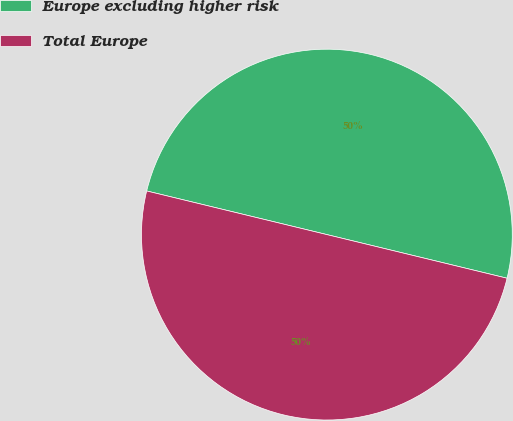Convert chart to OTSL. <chart><loc_0><loc_0><loc_500><loc_500><pie_chart><fcel>Europe excluding higher risk<fcel>Total Europe<nl><fcel>50.0%<fcel>50.0%<nl></chart> 